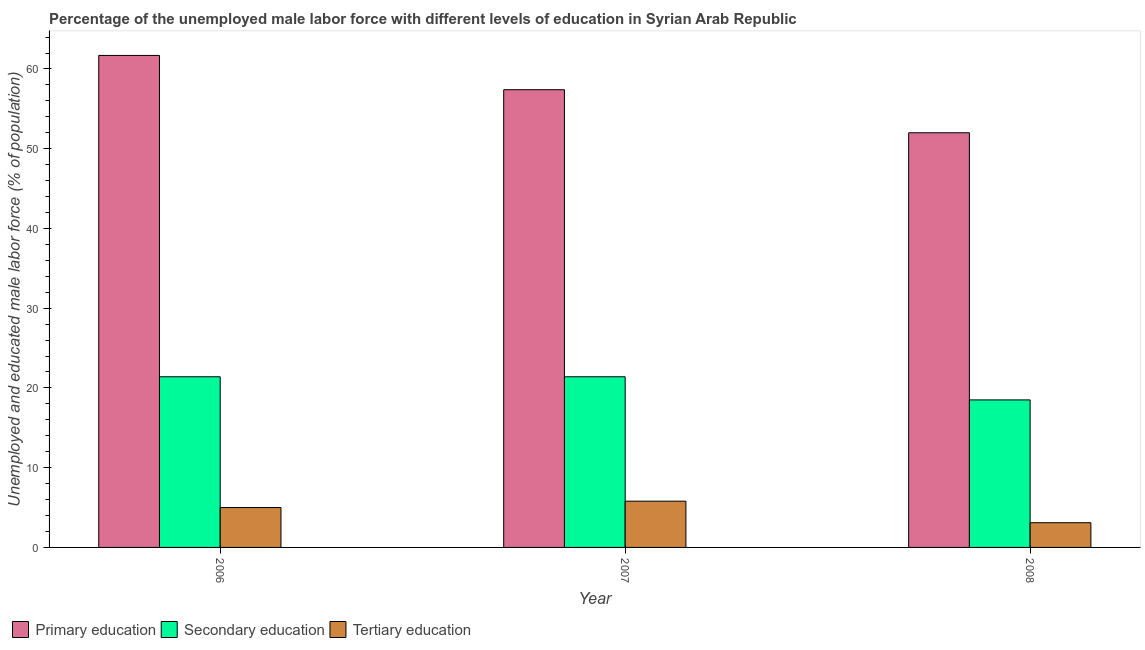Are the number of bars per tick equal to the number of legend labels?
Your response must be concise. Yes. Are the number of bars on each tick of the X-axis equal?
Provide a succinct answer. Yes. How many bars are there on the 2nd tick from the right?
Keep it short and to the point. 3. What is the percentage of male labor force who received primary education in 2007?
Provide a short and direct response. 57.4. Across all years, what is the maximum percentage of male labor force who received tertiary education?
Your answer should be very brief. 5.8. Across all years, what is the minimum percentage of male labor force who received tertiary education?
Your answer should be very brief. 3.1. What is the total percentage of male labor force who received primary education in the graph?
Your response must be concise. 171.1. What is the difference between the percentage of male labor force who received primary education in 2007 and that in 2008?
Your response must be concise. 5.4. What is the difference between the percentage of male labor force who received primary education in 2006 and the percentage of male labor force who received secondary education in 2008?
Give a very brief answer. 9.7. What is the average percentage of male labor force who received secondary education per year?
Provide a succinct answer. 20.43. What is the ratio of the percentage of male labor force who received primary education in 2006 to that in 2007?
Provide a short and direct response. 1.07. Is the difference between the percentage of male labor force who received secondary education in 2007 and 2008 greater than the difference between the percentage of male labor force who received primary education in 2007 and 2008?
Your answer should be compact. No. What is the difference between the highest and the second highest percentage of male labor force who received tertiary education?
Make the answer very short. 0.8. What is the difference between the highest and the lowest percentage of male labor force who received primary education?
Your answer should be compact. 9.7. What does the 2nd bar from the left in 2007 represents?
Give a very brief answer. Secondary education. Are all the bars in the graph horizontal?
Ensure brevity in your answer.  No. How many years are there in the graph?
Offer a very short reply. 3. What is the difference between two consecutive major ticks on the Y-axis?
Make the answer very short. 10. Does the graph contain any zero values?
Your response must be concise. No. Where does the legend appear in the graph?
Your answer should be very brief. Bottom left. How many legend labels are there?
Keep it short and to the point. 3. What is the title of the graph?
Provide a short and direct response. Percentage of the unemployed male labor force with different levels of education in Syrian Arab Republic. What is the label or title of the Y-axis?
Your response must be concise. Unemployed and educated male labor force (% of population). What is the Unemployed and educated male labor force (% of population) in Primary education in 2006?
Offer a terse response. 61.7. What is the Unemployed and educated male labor force (% of population) in Secondary education in 2006?
Make the answer very short. 21.4. What is the Unemployed and educated male labor force (% of population) in Primary education in 2007?
Keep it short and to the point. 57.4. What is the Unemployed and educated male labor force (% of population) of Secondary education in 2007?
Provide a succinct answer. 21.4. What is the Unemployed and educated male labor force (% of population) in Tertiary education in 2007?
Provide a succinct answer. 5.8. What is the Unemployed and educated male labor force (% of population) of Tertiary education in 2008?
Provide a succinct answer. 3.1. Across all years, what is the maximum Unemployed and educated male labor force (% of population) in Primary education?
Provide a short and direct response. 61.7. Across all years, what is the maximum Unemployed and educated male labor force (% of population) in Secondary education?
Make the answer very short. 21.4. Across all years, what is the maximum Unemployed and educated male labor force (% of population) of Tertiary education?
Offer a terse response. 5.8. Across all years, what is the minimum Unemployed and educated male labor force (% of population) of Primary education?
Keep it short and to the point. 52. Across all years, what is the minimum Unemployed and educated male labor force (% of population) in Tertiary education?
Provide a short and direct response. 3.1. What is the total Unemployed and educated male labor force (% of population) of Primary education in the graph?
Provide a short and direct response. 171.1. What is the total Unemployed and educated male labor force (% of population) in Secondary education in the graph?
Keep it short and to the point. 61.3. What is the difference between the Unemployed and educated male labor force (% of population) of Secondary education in 2006 and that in 2007?
Your response must be concise. 0. What is the difference between the Unemployed and educated male labor force (% of population) in Secondary education in 2006 and that in 2008?
Give a very brief answer. 2.9. What is the difference between the Unemployed and educated male labor force (% of population) in Primary education in 2007 and that in 2008?
Ensure brevity in your answer.  5.4. What is the difference between the Unemployed and educated male labor force (% of population) in Secondary education in 2007 and that in 2008?
Offer a very short reply. 2.9. What is the difference between the Unemployed and educated male labor force (% of population) of Primary education in 2006 and the Unemployed and educated male labor force (% of population) of Secondary education in 2007?
Give a very brief answer. 40.3. What is the difference between the Unemployed and educated male labor force (% of population) in Primary education in 2006 and the Unemployed and educated male labor force (% of population) in Tertiary education in 2007?
Ensure brevity in your answer.  55.9. What is the difference between the Unemployed and educated male labor force (% of population) of Primary education in 2006 and the Unemployed and educated male labor force (% of population) of Secondary education in 2008?
Provide a short and direct response. 43.2. What is the difference between the Unemployed and educated male labor force (% of population) in Primary education in 2006 and the Unemployed and educated male labor force (% of population) in Tertiary education in 2008?
Your answer should be very brief. 58.6. What is the difference between the Unemployed and educated male labor force (% of population) in Secondary education in 2006 and the Unemployed and educated male labor force (% of population) in Tertiary education in 2008?
Give a very brief answer. 18.3. What is the difference between the Unemployed and educated male labor force (% of population) of Primary education in 2007 and the Unemployed and educated male labor force (% of population) of Secondary education in 2008?
Provide a short and direct response. 38.9. What is the difference between the Unemployed and educated male labor force (% of population) of Primary education in 2007 and the Unemployed and educated male labor force (% of population) of Tertiary education in 2008?
Provide a succinct answer. 54.3. What is the average Unemployed and educated male labor force (% of population) in Primary education per year?
Your response must be concise. 57.03. What is the average Unemployed and educated male labor force (% of population) in Secondary education per year?
Give a very brief answer. 20.43. What is the average Unemployed and educated male labor force (% of population) in Tertiary education per year?
Provide a short and direct response. 4.63. In the year 2006, what is the difference between the Unemployed and educated male labor force (% of population) of Primary education and Unemployed and educated male labor force (% of population) of Secondary education?
Make the answer very short. 40.3. In the year 2006, what is the difference between the Unemployed and educated male labor force (% of population) in Primary education and Unemployed and educated male labor force (% of population) in Tertiary education?
Keep it short and to the point. 56.7. In the year 2007, what is the difference between the Unemployed and educated male labor force (% of population) of Primary education and Unemployed and educated male labor force (% of population) of Secondary education?
Your answer should be compact. 36. In the year 2007, what is the difference between the Unemployed and educated male labor force (% of population) of Primary education and Unemployed and educated male labor force (% of population) of Tertiary education?
Offer a very short reply. 51.6. In the year 2008, what is the difference between the Unemployed and educated male labor force (% of population) of Primary education and Unemployed and educated male labor force (% of population) of Secondary education?
Your answer should be compact. 33.5. In the year 2008, what is the difference between the Unemployed and educated male labor force (% of population) in Primary education and Unemployed and educated male labor force (% of population) in Tertiary education?
Your answer should be compact. 48.9. What is the ratio of the Unemployed and educated male labor force (% of population) in Primary education in 2006 to that in 2007?
Provide a succinct answer. 1.07. What is the ratio of the Unemployed and educated male labor force (% of population) of Secondary education in 2006 to that in 2007?
Provide a short and direct response. 1. What is the ratio of the Unemployed and educated male labor force (% of population) of Tertiary education in 2006 to that in 2007?
Provide a short and direct response. 0.86. What is the ratio of the Unemployed and educated male labor force (% of population) in Primary education in 2006 to that in 2008?
Keep it short and to the point. 1.19. What is the ratio of the Unemployed and educated male labor force (% of population) in Secondary education in 2006 to that in 2008?
Ensure brevity in your answer.  1.16. What is the ratio of the Unemployed and educated male labor force (% of population) in Tertiary education in 2006 to that in 2008?
Your answer should be compact. 1.61. What is the ratio of the Unemployed and educated male labor force (% of population) in Primary education in 2007 to that in 2008?
Give a very brief answer. 1.1. What is the ratio of the Unemployed and educated male labor force (% of population) in Secondary education in 2007 to that in 2008?
Offer a terse response. 1.16. What is the ratio of the Unemployed and educated male labor force (% of population) in Tertiary education in 2007 to that in 2008?
Ensure brevity in your answer.  1.87. What is the difference between the highest and the second highest Unemployed and educated male labor force (% of population) in Primary education?
Your answer should be very brief. 4.3. What is the difference between the highest and the second highest Unemployed and educated male labor force (% of population) in Secondary education?
Provide a short and direct response. 0. What is the difference between the highest and the second highest Unemployed and educated male labor force (% of population) of Tertiary education?
Keep it short and to the point. 0.8. What is the difference between the highest and the lowest Unemployed and educated male labor force (% of population) in Primary education?
Keep it short and to the point. 9.7. What is the difference between the highest and the lowest Unemployed and educated male labor force (% of population) in Secondary education?
Give a very brief answer. 2.9. 